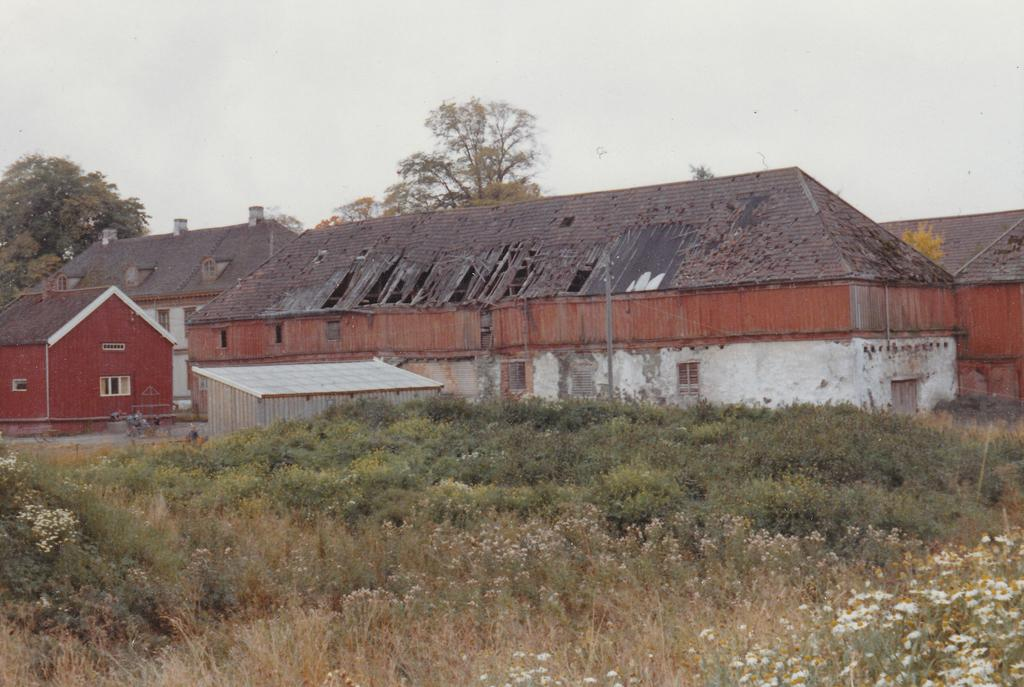What type of structures can be seen in the image? There are buildings and houses in the image. What other elements are present in the image besides structures? There are plants in the image. What can be seen in the background of the image? There are trees and the sky visible in the background of the image. What type of room is being offered in the image? There is no room being offered in the image; it features buildings, houses, plants, trees, and the sky. 